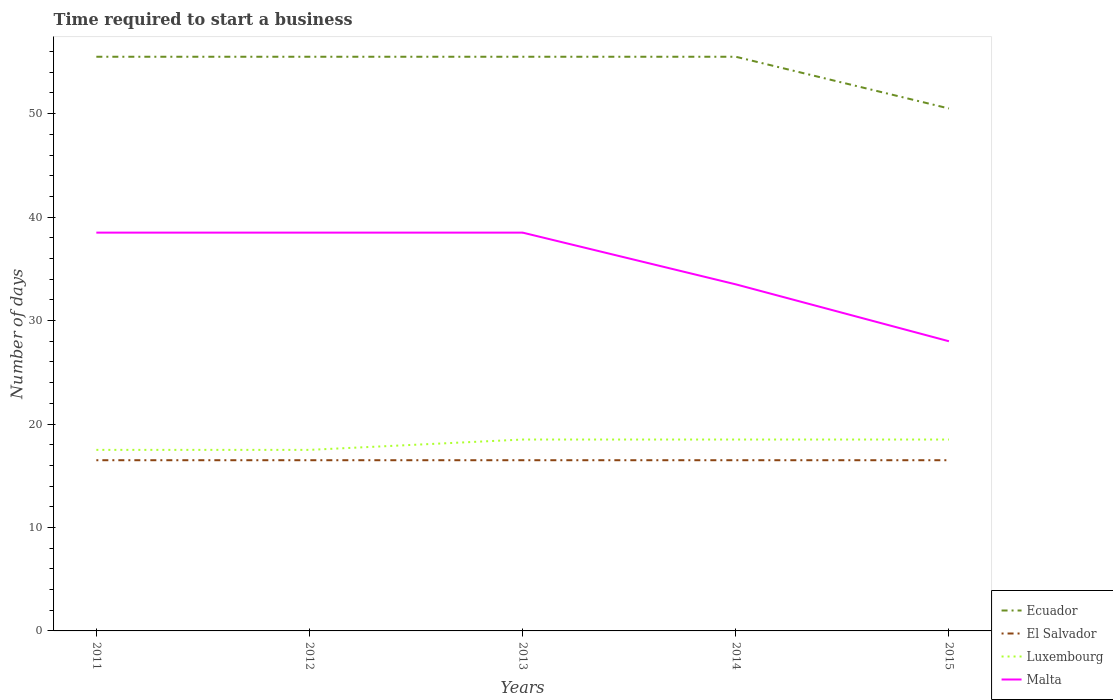Does the line corresponding to Luxembourg intersect with the line corresponding to El Salvador?
Keep it short and to the point. No. Is the number of lines equal to the number of legend labels?
Provide a succinct answer. Yes. In which year was the number of days required to start a business in Malta maximum?
Make the answer very short. 2015. What is the difference between the highest and the second highest number of days required to start a business in Malta?
Your response must be concise. 10.5. Is the number of days required to start a business in Luxembourg strictly greater than the number of days required to start a business in Ecuador over the years?
Your response must be concise. Yes. How many years are there in the graph?
Offer a very short reply. 5. Are the values on the major ticks of Y-axis written in scientific E-notation?
Make the answer very short. No. Does the graph contain grids?
Ensure brevity in your answer.  No. How many legend labels are there?
Your answer should be compact. 4. What is the title of the graph?
Provide a succinct answer. Time required to start a business. What is the label or title of the X-axis?
Provide a short and direct response. Years. What is the label or title of the Y-axis?
Your answer should be very brief. Number of days. What is the Number of days in Ecuador in 2011?
Your response must be concise. 55.5. What is the Number of days of El Salvador in 2011?
Provide a short and direct response. 16.5. What is the Number of days of Luxembourg in 2011?
Your answer should be compact. 17.5. What is the Number of days in Malta in 2011?
Offer a terse response. 38.5. What is the Number of days of Ecuador in 2012?
Give a very brief answer. 55.5. What is the Number of days in El Salvador in 2012?
Offer a terse response. 16.5. What is the Number of days in Luxembourg in 2012?
Provide a short and direct response. 17.5. What is the Number of days of Malta in 2012?
Give a very brief answer. 38.5. What is the Number of days of Ecuador in 2013?
Offer a very short reply. 55.5. What is the Number of days of Luxembourg in 2013?
Your response must be concise. 18.5. What is the Number of days in Malta in 2013?
Your answer should be very brief. 38.5. What is the Number of days in Ecuador in 2014?
Offer a terse response. 55.5. What is the Number of days of El Salvador in 2014?
Your answer should be compact. 16.5. What is the Number of days in Malta in 2014?
Make the answer very short. 33.5. What is the Number of days in Ecuador in 2015?
Provide a succinct answer. 50.5. Across all years, what is the maximum Number of days of Ecuador?
Keep it short and to the point. 55.5. Across all years, what is the maximum Number of days of El Salvador?
Your answer should be very brief. 16.5. Across all years, what is the maximum Number of days of Luxembourg?
Your response must be concise. 18.5. Across all years, what is the maximum Number of days in Malta?
Keep it short and to the point. 38.5. Across all years, what is the minimum Number of days in Ecuador?
Your answer should be very brief. 50.5. Across all years, what is the minimum Number of days in Luxembourg?
Offer a very short reply. 17.5. What is the total Number of days of Ecuador in the graph?
Ensure brevity in your answer.  272.5. What is the total Number of days of El Salvador in the graph?
Offer a very short reply. 82.5. What is the total Number of days of Luxembourg in the graph?
Offer a terse response. 90.5. What is the total Number of days of Malta in the graph?
Keep it short and to the point. 177. What is the difference between the Number of days of Ecuador in 2011 and that in 2012?
Your answer should be compact. 0. What is the difference between the Number of days of El Salvador in 2011 and that in 2012?
Provide a short and direct response. 0. What is the difference between the Number of days in Luxembourg in 2011 and that in 2013?
Offer a terse response. -1. What is the difference between the Number of days of Ecuador in 2011 and that in 2014?
Offer a terse response. 0. What is the difference between the Number of days in El Salvador in 2011 and that in 2014?
Your response must be concise. 0. What is the difference between the Number of days of Malta in 2011 and that in 2014?
Your response must be concise. 5. What is the difference between the Number of days of Ecuador in 2011 and that in 2015?
Ensure brevity in your answer.  5. What is the difference between the Number of days in El Salvador in 2011 and that in 2015?
Offer a terse response. 0. What is the difference between the Number of days of Malta in 2011 and that in 2015?
Your answer should be compact. 10.5. What is the difference between the Number of days in El Salvador in 2012 and that in 2013?
Offer a terse response. 0. What is the difference between the Number of days in Luxembourg in 2012 and that in 2013?
Offer a terse response. -1. What is the difference between the Number of days in Ecuador in 2012 and that in 2014?
Your answer should be compact. 0. What is the difference between the Number of days in El Salvador in 2012 and that in 2014?
Your response must be concise. 0. What is the difference between the Number of days of Luxembourg in 2012 and that in 2015?
Ensure brevity in your answer.  -1. What is the difference between the Number of days in Malta in 2012 and that in 2015?
Your answer should be very brief. 10.5. What is the difference between the Number of days in Ecuador in 2013 and that in 2014?
Provide a short and direct response. 0. What is the difference between the Number of days in Luxembourg in 2013 and that in 2014?
Keep it short and to the point. 0. What is the difference between the Number of days in Ecuador in 2013 and that in 2015?
Offer a very short reply. 5. What is the difference between the Number of days in El Salvador in 2013 and that in 2015?
Give a very brief answer. 0. What is the difference between the Number of days of Luxembourg in 2013 and that in 2015?
Offer a very short reply. 0. What is the difference between the Number of days in Malta in 2013 and that in 2015?
Give a very brief answer. 10.5. What is the difference between the Number of days of El Salvador in 2014 and that in 2015?
Your response must be concise. 0. What is the difference between the Number of days in Malta in 2014 and that in 2015?
Offer a very short reply. 5.5. What is the difference between the Number of days in El Salvador in 2011 and the Number of days in Luxembourg in 2012?
Offer a terse response. -1. What is the difference between the Number of days in Ecuador in 2011 and the Number of days in Luxembourg in 2013?
Your answer should be very brief. 37. What is the difference between the Number of days of El Salvador in 2011 and the Number of days of Luxembourg in 2013?
Make the answer very short. -2. What is the difference between the Number of days of El Salvador in 2011 and the Number of days of Malta in 2013?
Your answer should be compact. -22. What is the difference between the Number of days of Ecuador in 2011 and the Number of days of El Salvador in 2014?
Give a very brief answer. 39. What is the difference between the Number of days in El Salvador in 2011 and the Number of days in Malta in 2014?
Offer a very short reply. -17. What is the difference between the Number of days in Ecuador in 2011 and the Number of days in El Salvador in 2015?
Offer a very short reply. 39. What is the difference between the Number of days of Ecuador in 2012 and the Number of days of Malta in 2013?
Make the answer very short. 17. What is the difference between the Number of days of El Salvador in 2012 and the Number of days of Luxembourg in 2013?
Provide a succinct answer. -2. What is the difference between the Number of days in El Salvador in 2012 and the Number of days in Malta in 2013?
Your response must be concise. -22. What is the difference between the Number of days of Ecuador in 2012 and the Number of days of Malta in 2014?
Make the answer very short. 22. What is the difference between the Number of days in El Salvador in 2012 and the Number of days in Luxembourg in 2014?
Ensure brevity in your answer.  -2. What is the difference between the Number of days of El Salvador in 2012 and the Number of days of Malta in 2014?
Your answer should be very brief. -17. What is the difference between the Number of days in Luxembourg in 2012 and the Number of days in Malta in 2014?
Offer a terse response. -16. What is the difference between the Number of days of Ecuador in 2012 and the Number of days of Malta in 2015?
Offer a terse response. 27.5. What is the difference between the Number of days in Luxembourg in 2012 and the Number of days in Malta in 2015?
Give a very brief answer. -10.5. What is the difference between the Number of days of Ecuador in 2013 and the Number of days of Malta in 2014?
Offer a terse response. 22. What is the difference between the Number of days in Luxembourg in 2013 and the Number of days in Malta in 2014?
Ensure brevity in your answer.  -15. What is the difference between the Number of days in Ecuador in 2013 and the Number of days in El Salvador in 2015?
Keep it short and to the point. 39. What is the difference between the Number of days in El Salvador in 2013 and the Number of days in Luxembourg in 2015?
Keep it short and to the point. -2. What is the difference between the Number of days of El Salvador in 2013 and the Number of days of Malta in 2015?
Provide a succinct answer. -11.5. What is the difference between the Number of days in Luxembourg in 2013 and the Number of days in Malta in 2015?
Your answer should be very brief. -9.5. What is the difference between the Number of days in El Salvador in 2014 and the Number of days in Malta in 2015?
Offer a terse response. -11.5. What is the difference between the Number of days in Luxembourg in 2014 and the Number of days in Malta in 2015?
Ensure brevity in your answer.  -9.5. What is the average Number of days in Ecuador per year?
Give a very brief answer. 54.5. What is the average Number of days in Luxembourg per year?
Make the answer very short. 18.1. What is the average Number of days in Malta per year?
Ensure brevity in your answer.  35.4. In the year 2011, what is the difference between the Number of days in Ecuador and Number of days in Luxembourg?
Offer a very short reply. 38. In the year 2011, what is the difference between the Number of days of El Salvador and Number of days of Luxembourg?
Offer a very short reply. -1. In the year 2011, what is the difference between the Number of days of Luxembourg and Number of days of Malta?
Offer a terse response. -21. In the year 2012, what is the difference between the Number of days of El Salvador and Number of days of Luxembourg?
Ensure brevity in your answer.  -1. In the year 2012, what is the difference between the Number of days of El Salvador and Number of days of Malta?
Keep it short and to the point. -22. In the year 2012, what is the difference between the Number of days of Luxembourg and Number of days of Malta?
Keep it short and to the point. -21. In the year 2013, what is the difference between the Number of days in Ecuador and Number of days in El Salvador?
Your answer should be very brief. 39. In the year 2013, what is the difference between the Number of days in Ecuador and Number of days in Luxembourg?
Offer a terse response. 37. In the year 2013, what is the difference between the Number of days in Ecuador and Number of days in Malta?
Provide a short and direct response. 17. In the year 2013, what is the difference between the Number of days in El Salvador and Number of days in Malta?
Provide a succinct answer. -22. In the year 2014, what is the difference between the Number of days in Ecuador and Number of days in El Salvador?
Ensure brevity in your answer.  39. In the year 2014, what is the difference between the Number of days of Ecuador and Number of days of Malta?
Keep it short and to the point. 22. In the year 2014, what is the difference between the Number of days of El Salvador and Number of days of Malta?
Make the answer very short. -17. In the year 2015, what is the difference between the Number of days in Ecuador and Number of days in El Salvador?
Your answer should be compact. 34. In the year 2015, what is the difference between the Number of days in Ecuador and Number of days in Luxembourg?
Provide a succinct answer. 32. In the year 2015, what is the difference between the Number of days in El Salvador and Number of days in Malta?
Offer a terse response. -11.5. In the year 2015, what is the difference between the Number of days in Luxembourg and Number of days in Malta?
Give a very brief answer. -9.5. What is the ratio of the Number of days of El Salvador in 2011 to that in 2012?
Offer a very short reply. 1. What is the ratio of the Number of days of Luxembourg in 2011 to that in 2012?
Provide a succinct answer. 1. What is the ratio of the Number of days of El Salvador in 2011 to that in 2013?
Your response must be concise. 1. What is the ratio of the Number of days of Luxembourg in 2011 to that in 2013?
Your answer should be very brief. 0.95. What is the ratio of the Number of days in Malta in 2011 to that in 2013?
Make the answer very short. 1. What is the ratio of the Number of days of Luxembourg in 2011 to that in 2014?
Give a very brief answer. 0.95. What is the ratio of the Number of days of Malta in 2011 to that in 2014?
Your answer should be very brief. 1.15. What is the ratio of the Number of days of Ecuador in 2011 to that in 2015?
Ensure brevity in your answer.  1.1. What is the ratio of the Number of days in Luxembourg in 2011 to that in 2015?
Give a very brief answer. 0.95. What is the ratio of the Number of days in Malta in 2011 to that in 2015?
Your response must be concise. 1.38. What is the ratio of the Number of days of El Salvador in 2012 to that in 2013?
Your answer should be very brief. 1. What is the ratio of the Number of days in Luxembourg in 2012 to that in 2013?
Give a very brief answer. 0.95. What is the ratio of the Number of days in Malta in 2012 to that in 2013?
Make the answer very short. 1. What is the ratio of the Number of days of Ecuador in 2012 to that in 2014?
Offer a very short reply. 1. What is the ratio of the Number of days of El Salvador in 2012 to that in 2014?
Ensure brevity in your answer.  1. What is the ratio of the Number of days in Luxembourg in 2012 to that in 2014?
Your answer should be very brief. 0.95. What is the ratio of the Number of days in Malta in 2012 to that in 2014?
Offer a terse response. 1.15. What is the ratio of the Number of days of Ecuador in 2012 to that in 2015?
Offer a very short reply. 1.1. What is the ratio of the Number of days of Luxembourg in 2012 to that in 2015?
Offer a terse response. 0.95. What is the ratio of the Number of days of Malta in 2012 to that in 2015?
Give a very brief answer. 1.38. What is the ratio of the Number of days in Ecuador in 2013 to that in 2014?
Offer a very short reply. 1. What is the ratio of the Number of days of El Salvador in 2013 to that in 2014?
Ensure brevity in your answer.  1. What is the ratio of the Number of days in Malta in 2013 to that in 2014?
Offer a very short reply. 1.15. What is the ratio of the Number of days of Ecuador in 2013 to that in 2015?
Your answer should be very brief. 1.1. What is the ratio of the Number of days of El Salvador in 2013 to that in 2015?
Your answer should be very brief. 1. What is the ratio of the Number of days of Luxembourg in 2013 to that in 2015?
Your answer should be compact. 1. What is the ratio of the Number of days in Malta in 2013 to that in 2015?
Give a very brief answer. 1.38. What is the ratio of the Number of days in Ecuador in 2014 to that in 2015?
Your answer should be compact. 1.1. What is the ratio of the Number of days in Malta in 2014 to that in 2015?
Your answer should be very brief. 1.2. What is the difference between the highest and the second highest Number of days in Ecuador?
Offer a very short reply. 0. What is the difference between the highest and the second highest Number of days in Luxembourg?
Ensure brevity in your answer.  0. What is the difference between the highest and the second highest Number of days in Malta?
Give a very brief answer. 0. What is the difference between the highest and the lowest Number of days of El Salvador?
Provide a succinct answer. 0. What is the difference between the highest and the lowest Number of days of Luxembourg?
Your answer should be compact. 1. What is the difference between the highest and the lowest Number of days of Malta?
Your answer should be compact. 10.5. 